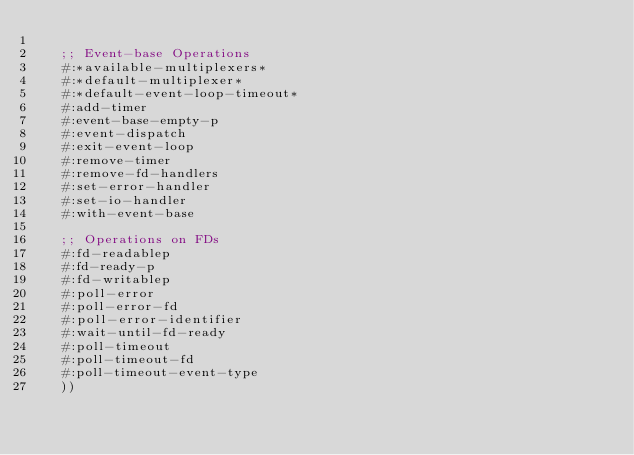<code> <loc_0><loc_0><loc_500><loc_500><_Lisp_>
   ;; Event-base Operations
   #:*available-multiplexers*
   #:*default-multiplexer*
   #:*default-event-loop-timeout*
   #:add-timer
   #:event-base-empty-p
   #:event-dispatch
   #:exit-event-loop
   #:remove-timer
   #:remove-fd-handlers
   #:set-error-handler
   #:set-io-handler
   #:with-event-base

   ;; Operations on FDs
   #:fd-readablep
   #:fd-ready-p
   #:fd-writablep
   #:poll-error
   #:poll-error-fd
   #:poll-error-identifier
   #:wait-until-fd-ready
   #:poll-timeout
   #:poll-timeout-fd
   #:poll-timeout-event-type
   ))
</code> 